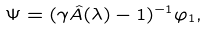Convert formula to latex. <formula><loc_0><loc_0><loc_500><loc_500>\Psi = ( \gamma \hat { A } ( \lambda ) - 1 ) ^ { - 1 } \varphi _ { 1 } ,</formula> 